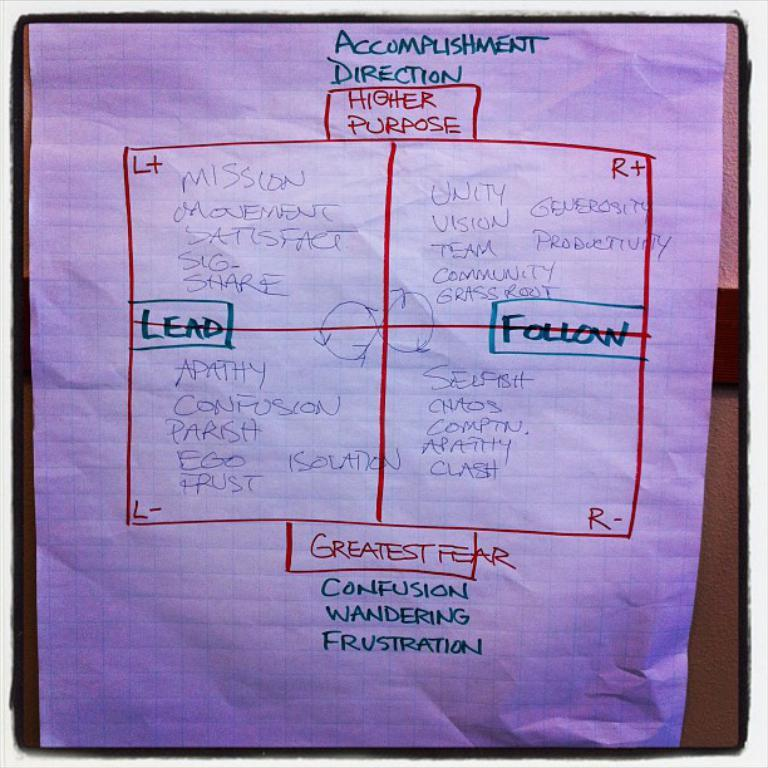What is on the paper that is visible in the image? There is text on the paper in the image. What is the paper placed on or attached to? The paper is on an object. Reasoning: Let' Let's think step by step in order to produce the conversation. We start by identifying the main subject in the image, which is the paper with text. Then, we expand the conversation to include the object that the paper is on or attached to. Each question is designed to elicit a specific detail about the image that is known from the provided facts. Absurd Question/Answer: How many frogs are sitting on the bed in the image? There is no bed or frogs present in the image. What type of fear is depicted in the image? There is no fear depicted in the image; it only features a paper with text on an object. 